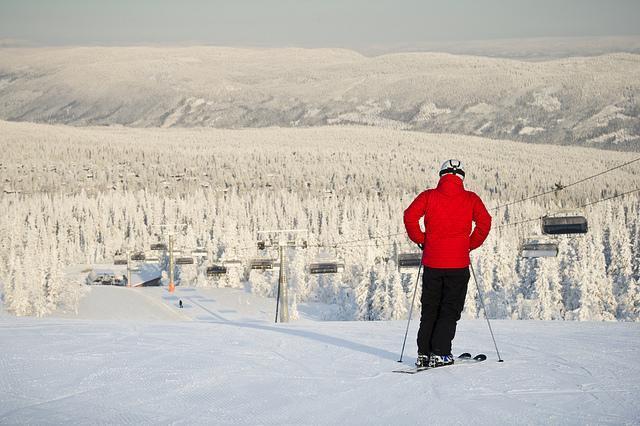How many bears are wearing a hat in the picture?
Give a very brief answer. 0. 